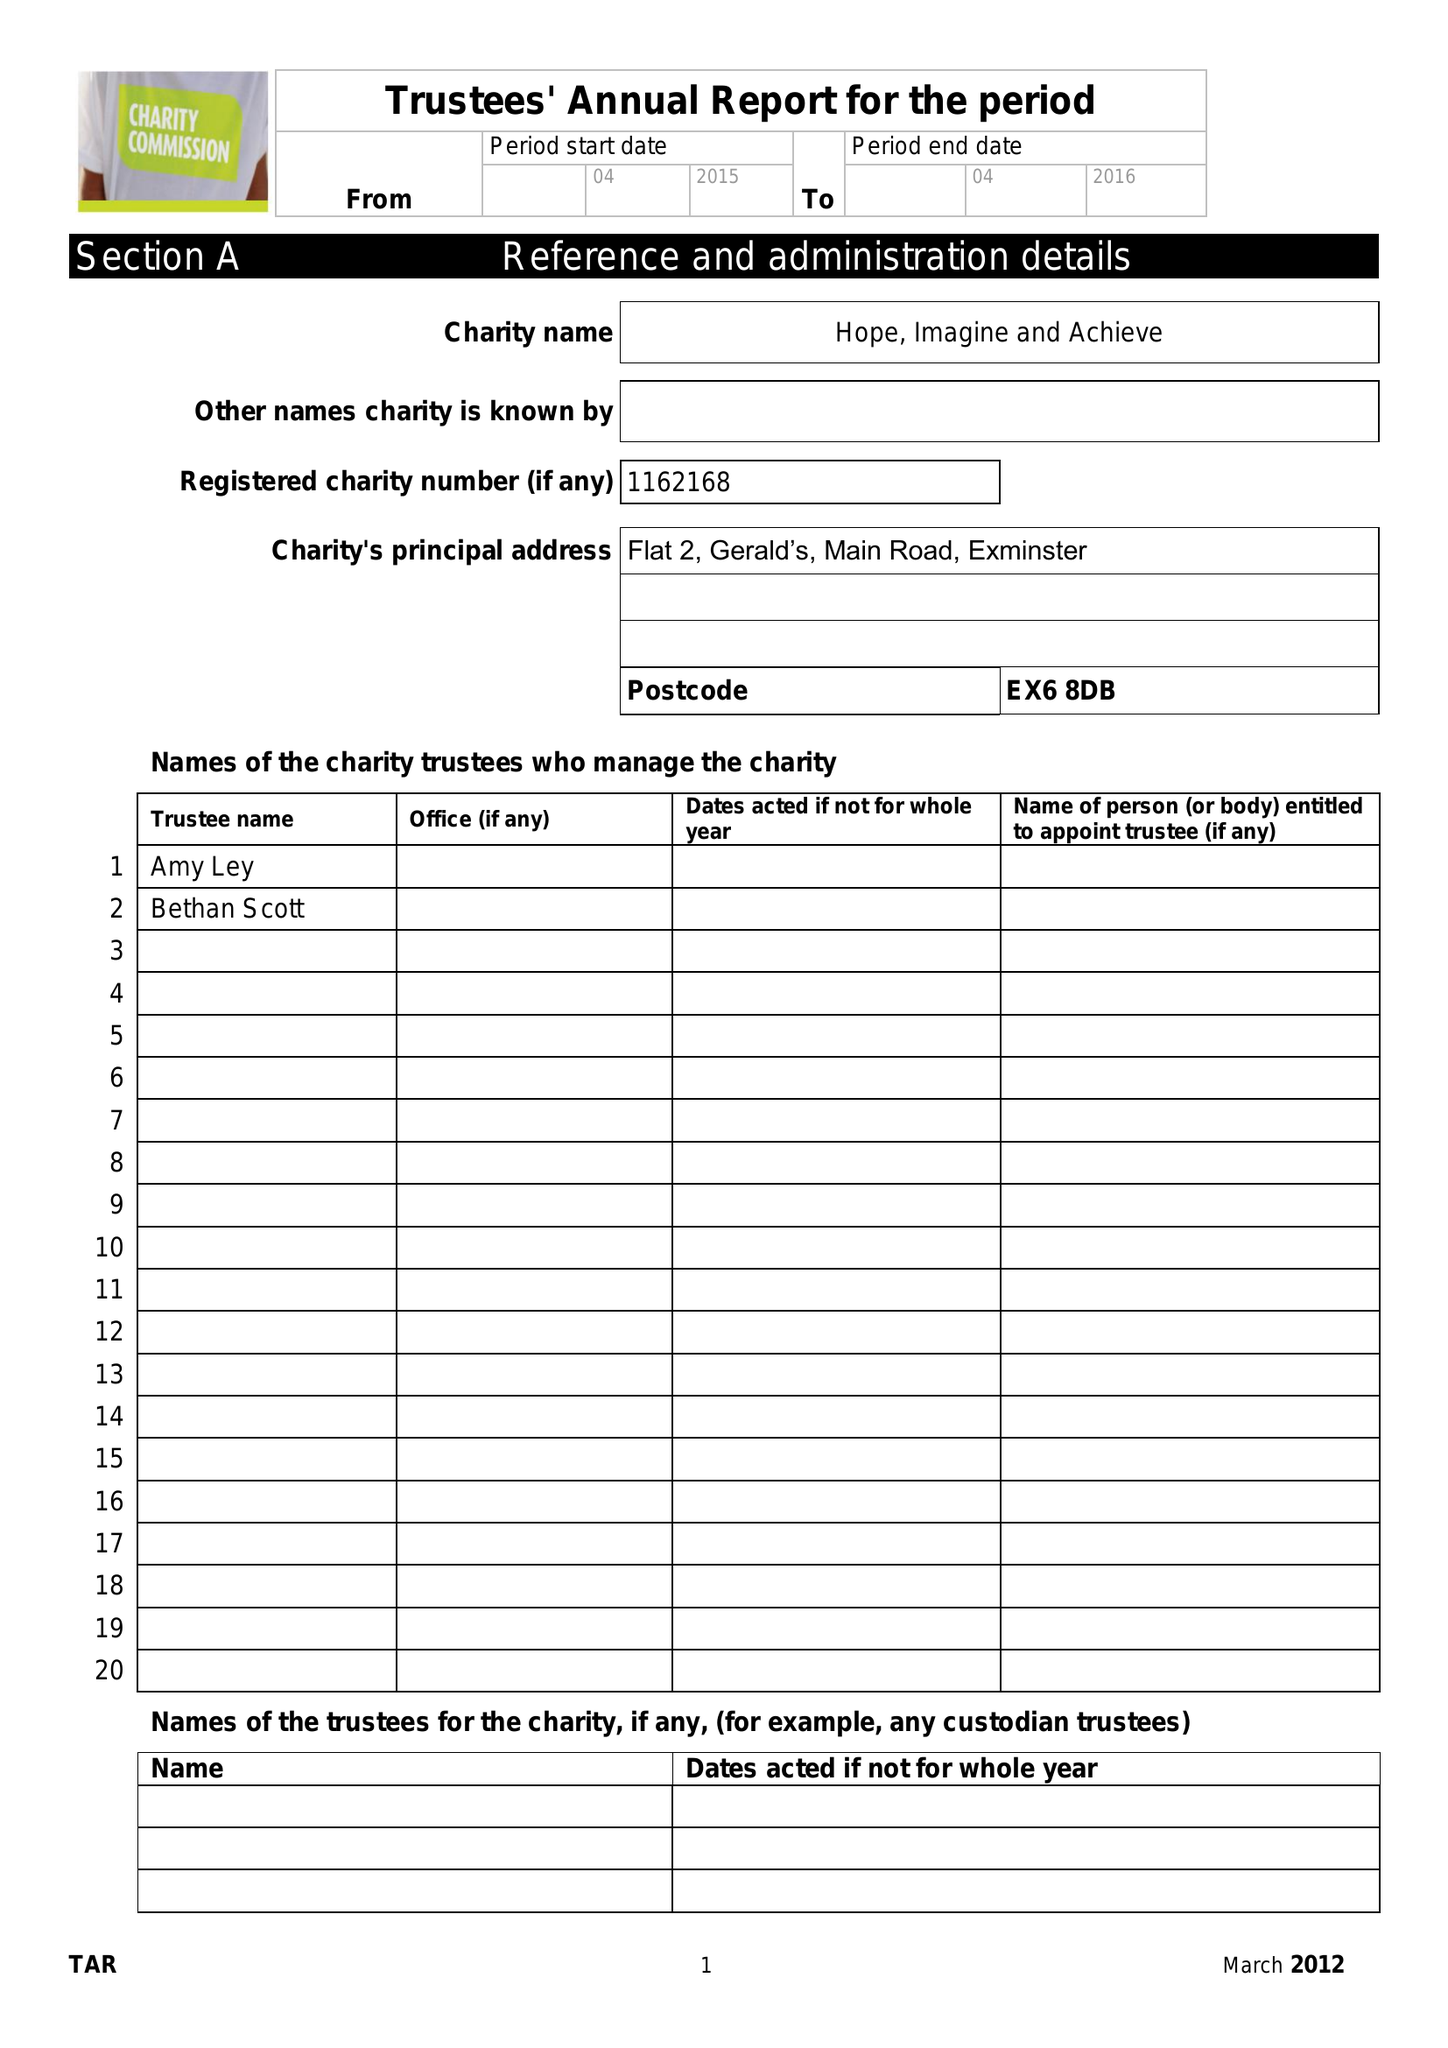What is the value for the charity_number?
Answer the question using a single word or phrase. 1162168 